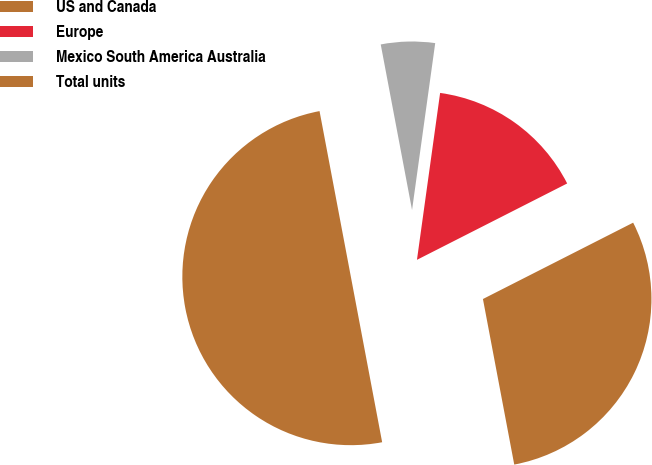Convert chart. <chart><loc_0><loc_0><loc_500><loc_500><pie_chart><fcel>US and Canada<fcel>Europe<fcel>Mexico South America Australia<fcel>Total units<nl><fcel>29.51%<fcel>15.32%<fcel>5.17%<fcel>50.0%<nl></chart> 